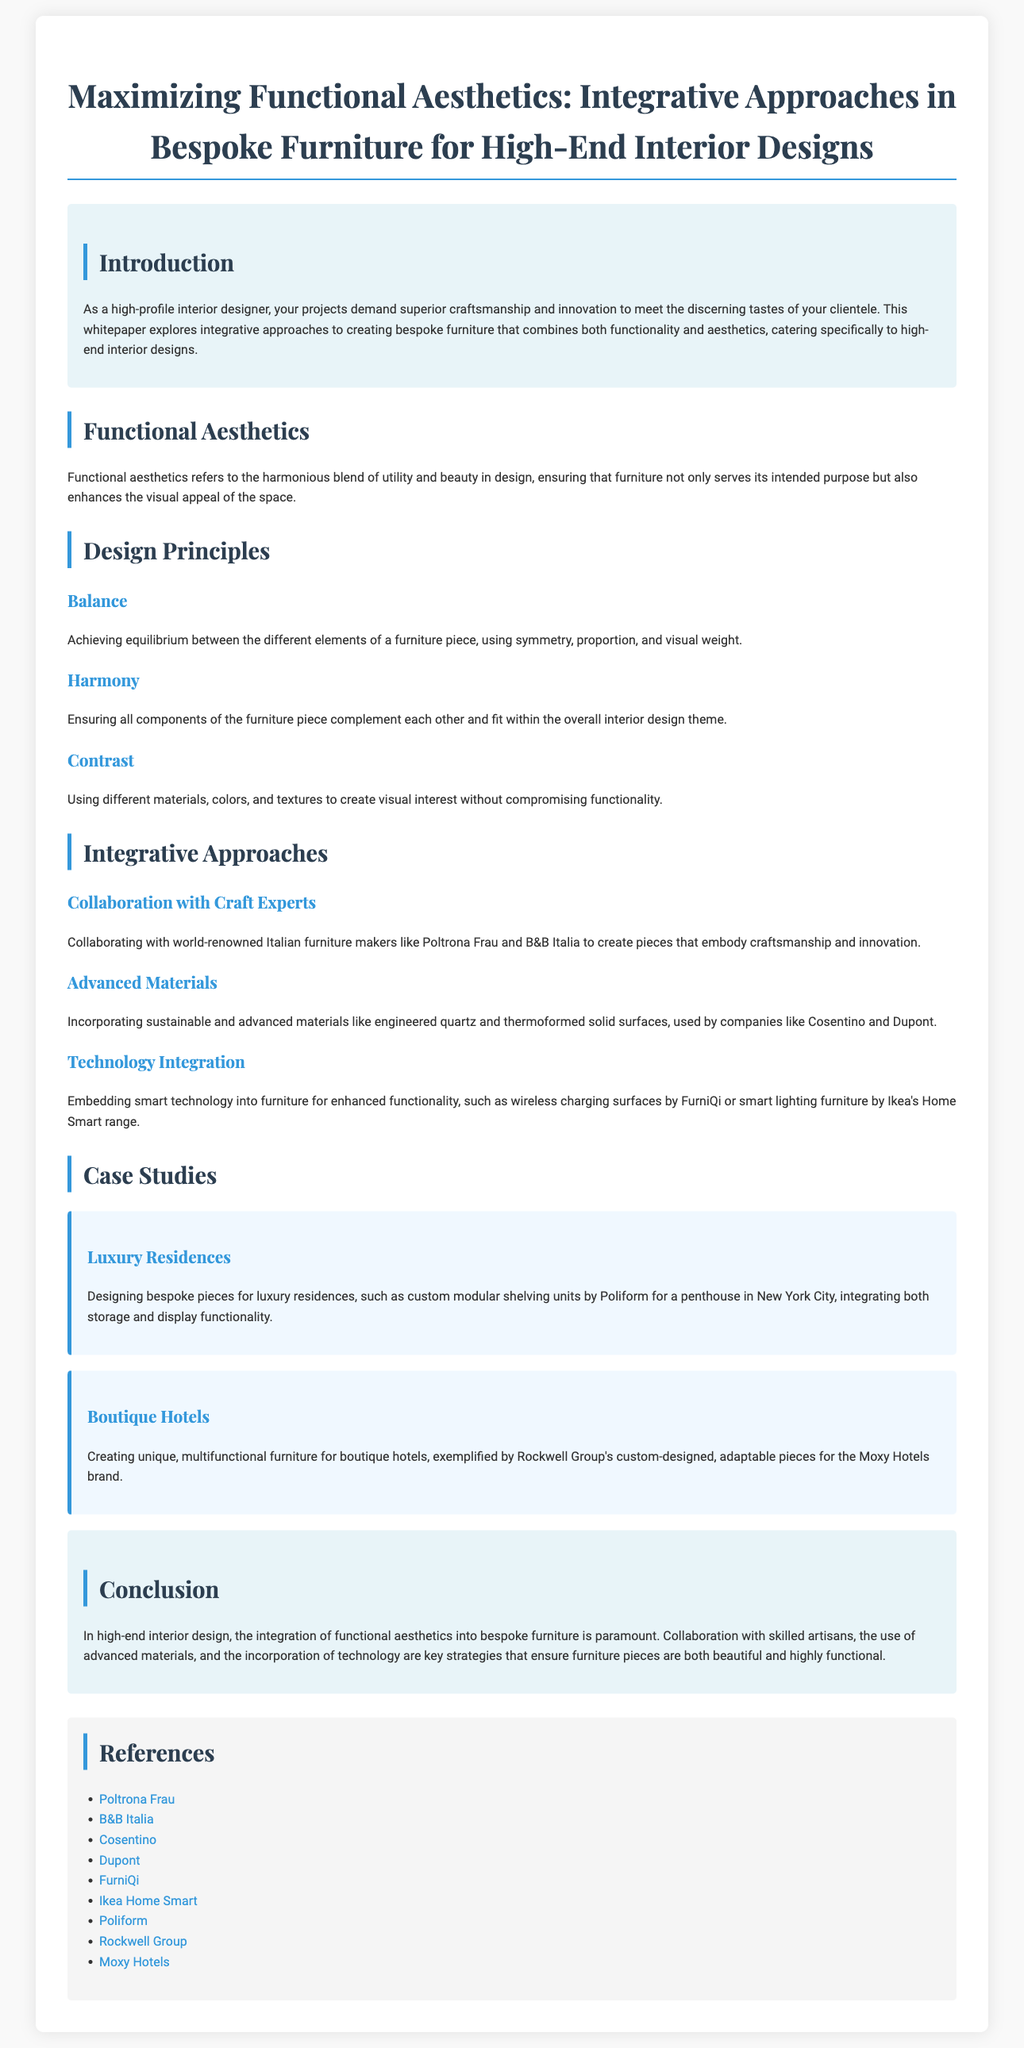What is the title of the document? The title is stated prominently at the top of the document in a larger font.
Answer: Maximizing Functional Aesthetics: Integrative Approaches in Bespoke Furniture for High-End Interior Designs What does functional aesthetics refer to? The definition is provided in the section discussing functional aesthetics, summarizing its importance in design.
Answer: The harmonious blend of utility and beauty in design Who are two mentioned Italian furniture makers? The document lists these companies as collaborators in the design process, showcasing craftsmanship.
Answer: Poltrona Frau and B&B Italia What are two advanced materials mentioned? The document specifies sustainable and advanced materials that can be incorporated into furniture.
Answer: Engineered quartz and thermoformed solid surfaces What is one of the design principles outlined in the paper? The document provides specific design principles that are essential for creating appealing furniture pieces.
Answer: Balance Which brand's custom furniture was designed for boutique hotels? The case study discusses a specific brand known for its unique designs for hotel settings.
Answer: Moxy Hotels How many case studies are presented in the document? The document presents specific sections dedicated to examples of bespoke furniture designs in various categories.
Answer: Two What is one benefit of technology integration in furniture? The document highlights features added to furniture which enhance its functionality.
Answer: Enhanced functionality What overarching theme is emphasized in the conclusion? The conclusion summarizes the importance of various strategies in ensuring furniture meets design goals.
Answer: Integration of functional aesthetics 